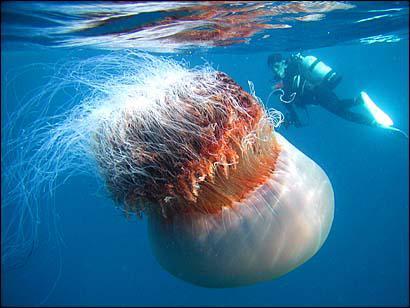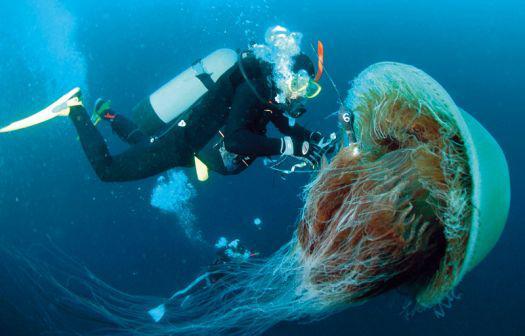The first image is the image on the left, the second image is the image on the right. Analyze the images presented: Is the assertion "There is at least one person without an airtank." valid? Answer yes or no. No. The first image is the image on the left, the second image is the image on the right. Evaluate the accuracy of this statement regarding the images: "Each image includes a person wearing a scuba-type wetsuit.". Is it true? Answer yes or no. Yes. 